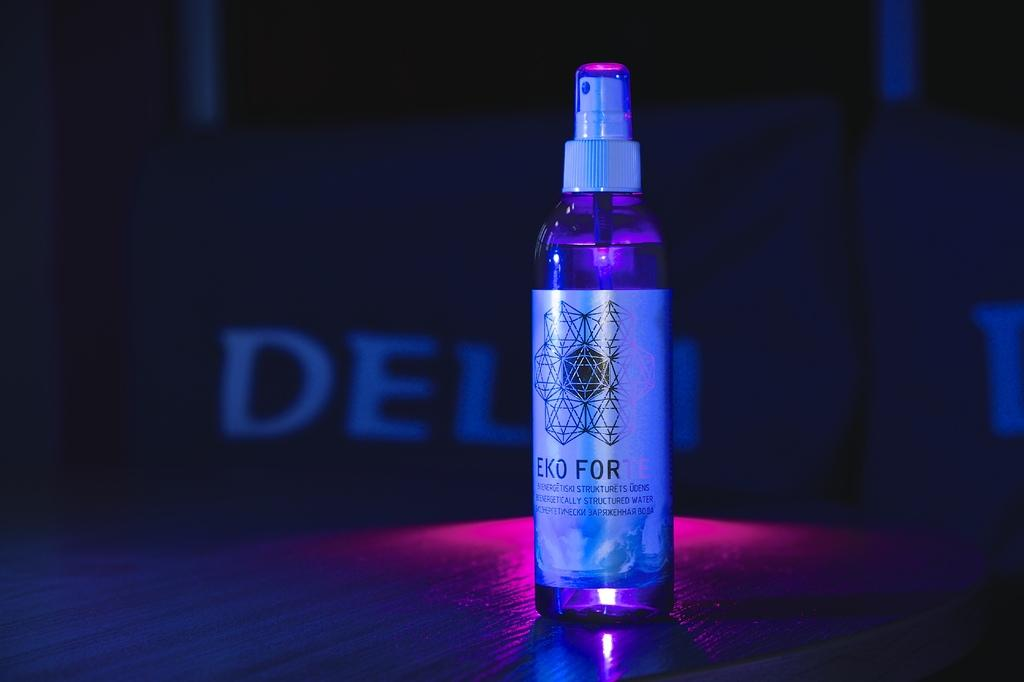<image>
Describe the image concisely. an EKO FORTE spray bottle filled with the liquid contents. 